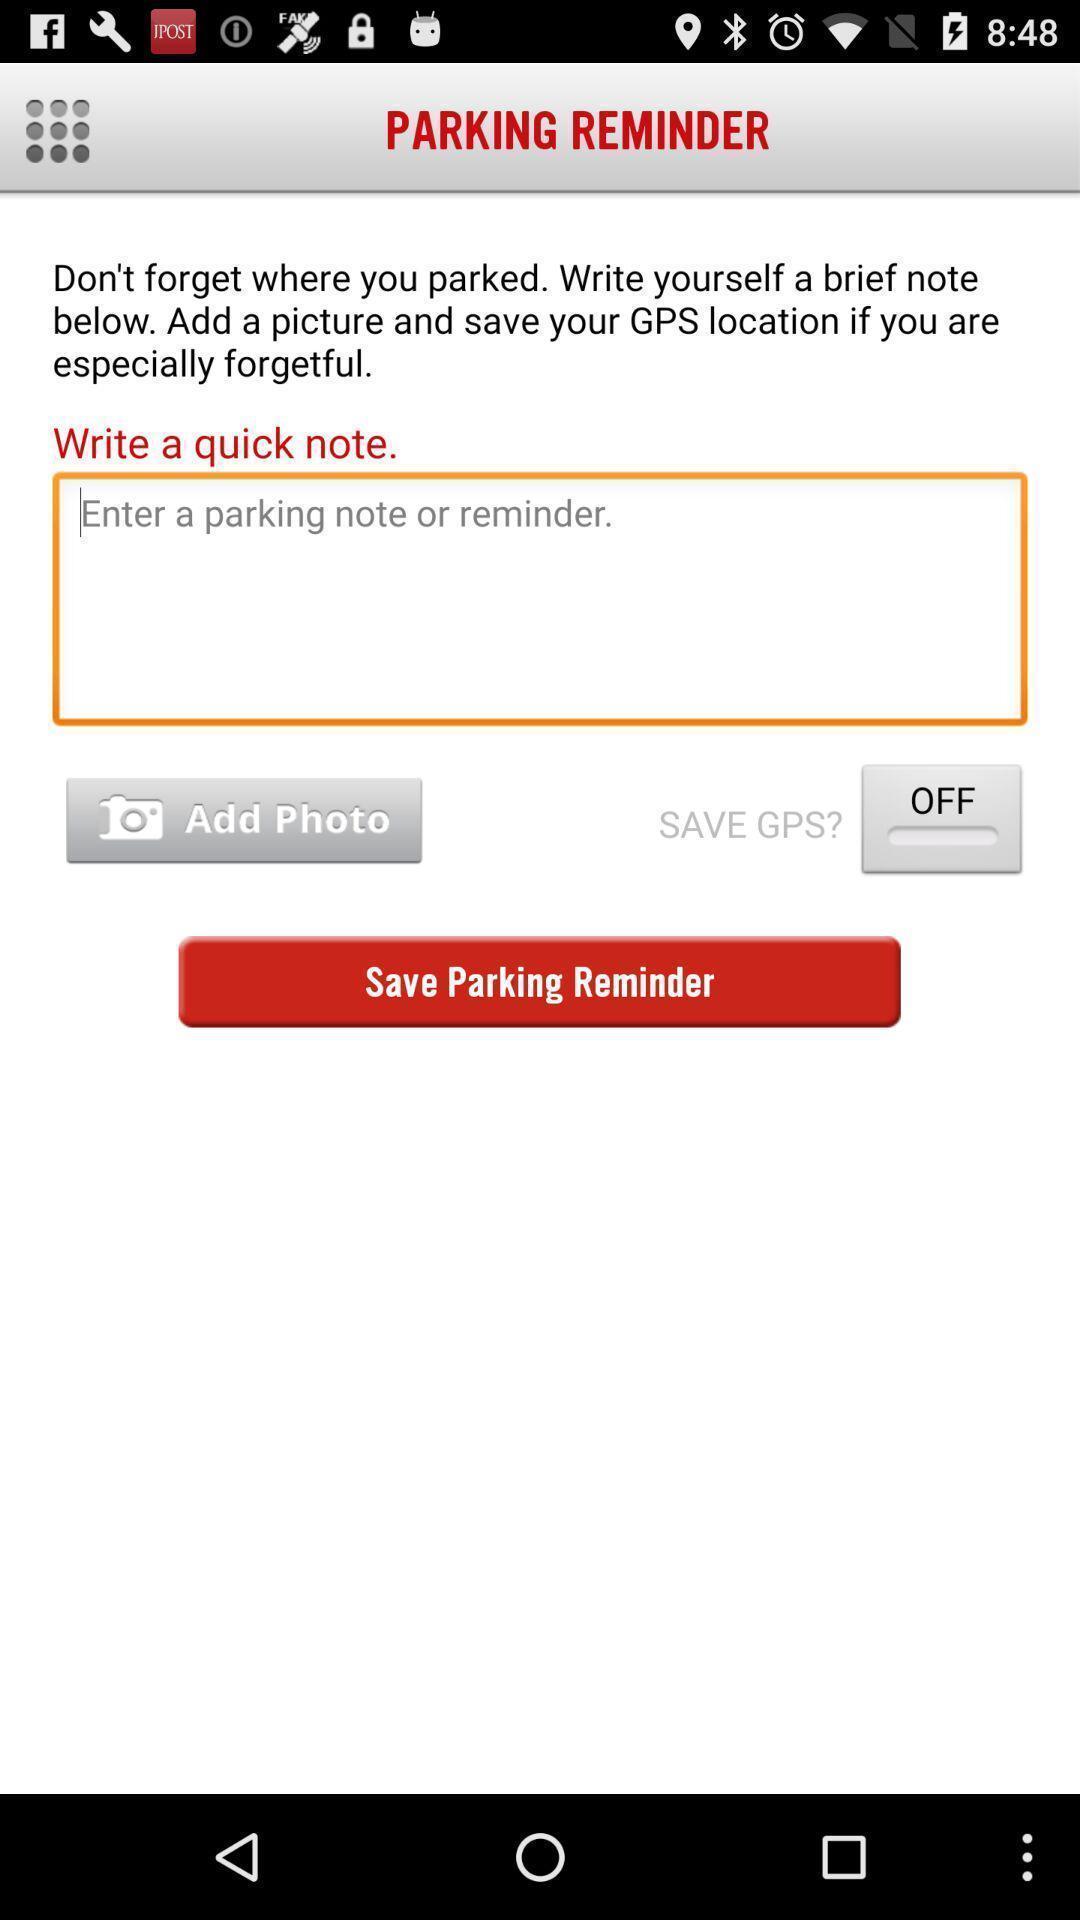Tell me what you see in this picture. Screen showing a parking remainder. 